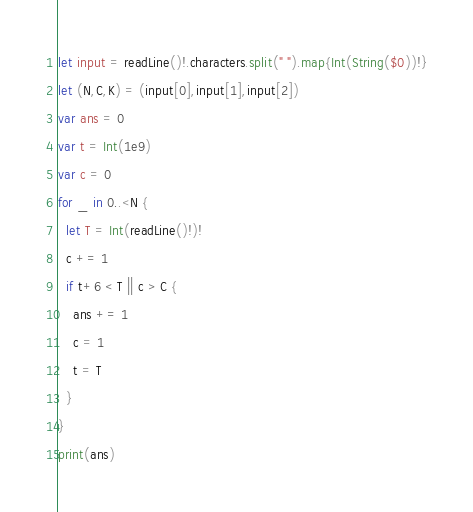Convert code to text. <code><loc_0><loc_0><loc_500><loc_500><_Swift_>let input = readLine()!.characters.split(" ").map{Int(String($0))!}
let (N,C,K) = (input[0],input[1],input[2])
var ans = 0
var t = Int(1e9)
var c = 0
for _ in 0..<N {
  let T = Int(readLine()!)!
  c += 1
  if t+6 < T || c > C {
    ans += 1
    c = 1
    t = T
  }
}
print(ans)</code> 